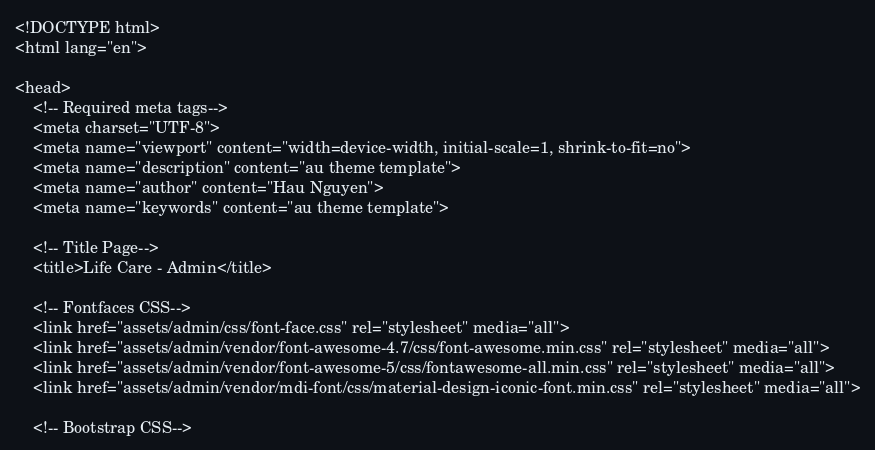<code> <loc_0><loc_0><loc_500><loc_500><_PHP_><!DOCTYPE html>
<html lang="en">

<head>
    <!-- Required meta tags-->
    <meta charset="UTF-8">
    <meta name="viewport" content="width=device-width, initial-scale=1, shrink-to-fit=no">
    <meta name="description" content="au theme template">
    <meta name="author" content="Hau Nguyen">
    <meta name="keywords" content="au theme template">

    <!-- Title Page-->
    <title>Life Care - Admin</title>

    <!-- Fontfaces CSS-->
    <link href="assets/admin/css/font-face.css" rel="stylesheet" media="all">
    <link href="assets/admin/vendor/font-awesome-4.7/css/font-awesome.min.css" rel="stylesheet" media="all">
    <link href="assets/admin/vendor/font-awesome-5/css/fontawesome-all.min.css" rel="stylesheet" media="all">
    <link href="assets/admin/vendor/mdi-font/css/material-design-iconic-font.min.css" rel="stylesheet" media="all">

    <!-- Bootstrap CSS--></code> 